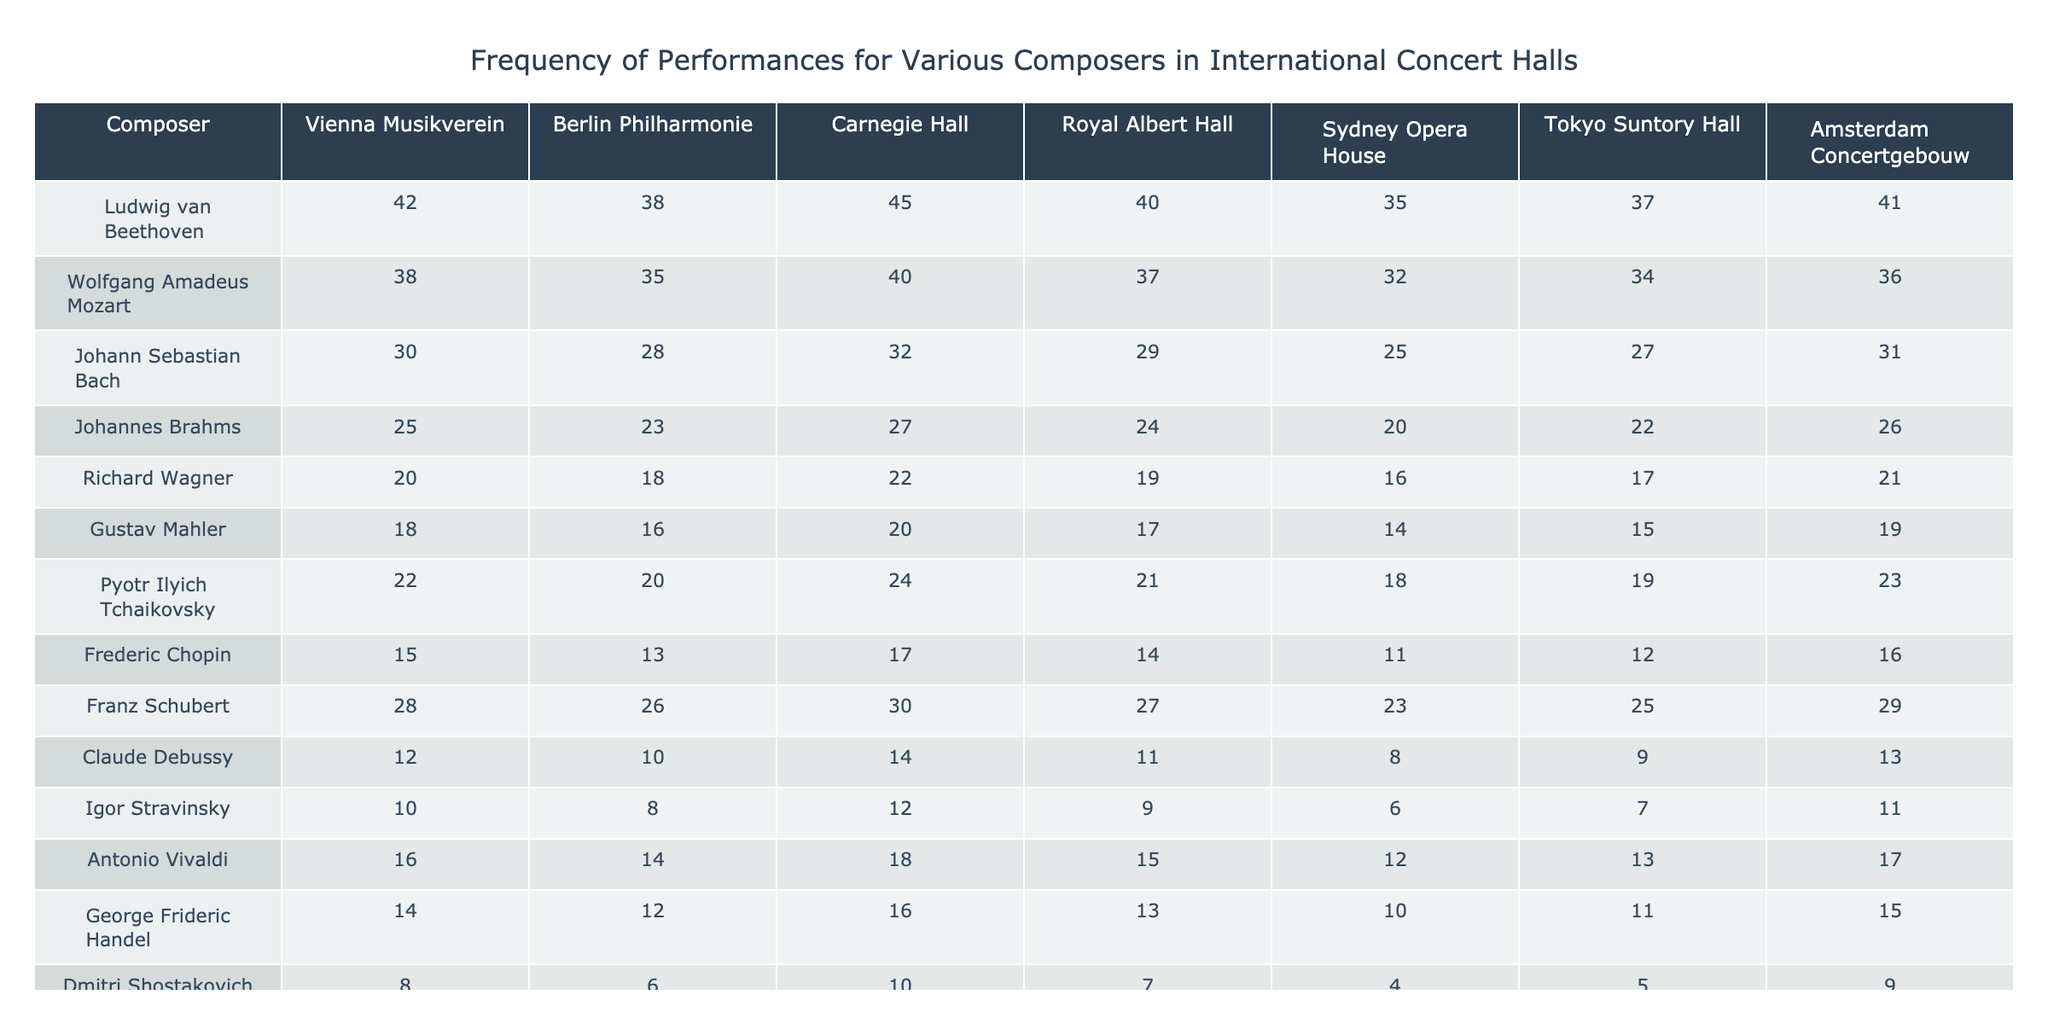What is the highest frequency of performances for Ludwig van Beethoven? The frequency values for Ludwig van Beethoven in the table are as follows: 42, 38, 45, 40, 35, 37, 41. The highest value amongst these is 45 at Carnegie Hall.
Answer: 45 Which composer has the least performances at the Sydney Opera House? The frequency values for all composers at Sydney Opera House are: 35, 32, 25, 20, 16, 14, 18, 11, 23, 8, 6, 12. The lowest value is 6 for Dmitri Shostakovich.
Answer: Dmitri Shostakovich What is the average frequency of performances for Mozart across all venues? The frequencies for Mozart across all venues are: 38, 35, 40, 37, 32, 34, 36. Adding these values gives 252. There are 7 venues, so the average is 252 / 7 = 36.
Answer: 36 How many more performances does George Frideric Handel have than Claude Debussy at the Berlin Philharmonie? George Frideric Handel has 12 performances while Claude Debussy has 10 at the Berlin Philharmonie. 12 - 10 = 2, thus Handel has 2 more performances than Debussy.
Answer: 2 Is Richard Wagner performed more often at the Royal Albert Hall than Johann Sebastian Bach? Richard Wagner has 19 performances and Johann Sebastian Bach has 29 performances at Royal Albert Hall. Since 19 is less than 29, the answer is no.
Answer: No Which composer has the most consistent performance counts across all venues? To assess consistency, we look at the range (max - min) of each composer’s performances. For Tchaikovsky, the performances range from 18 to 24 (max - min = 6), which is lower than others. Thus, he exhibits the most consistency.
Answer: Pyotr Ilyich Tchaikovsky What is the total number of performances for all composers at the Vienna Musikverein? The performances at Vienna Musikverein are: 42, 38, 30, 25, 20, 18, 22, 15, 28, 12, 10, 16, 14, 8, 11. The total is obtained by summing these values, resulting in 315.
Answer: 315 Which two composers have the closest performance numbers at the Tokyo Suntory Hall? The performances at Tokyo Suntory Hall are: 37, 34, 27, 22, 17, 15, 19, 12, 25, 9, 7, 13, 11, 5, 8. Looking for the closest values, we find that Ravel (8) and Stravinsky (7) have the least difference of 1.
Answer: Maurice Ravel and Igor Stravinsky What percentage of performances did Johannes Brahms achieve compared to the highest performer at the Royal Albert Hall? Johannes Brahms has 24 performances while Beethoven has the highest with 40 at Royal Albert Hall. To calculate the percentage: (24 / 40) * 100 = 60%.
Answer: 60% Did any two composers have the same number of performances at any venue? Checking the table, we find that at Tokyo Suntory Hall both Chopin and Stravinsky have 12 performances. Therefore, the answer is yes.
Answer: Yes 